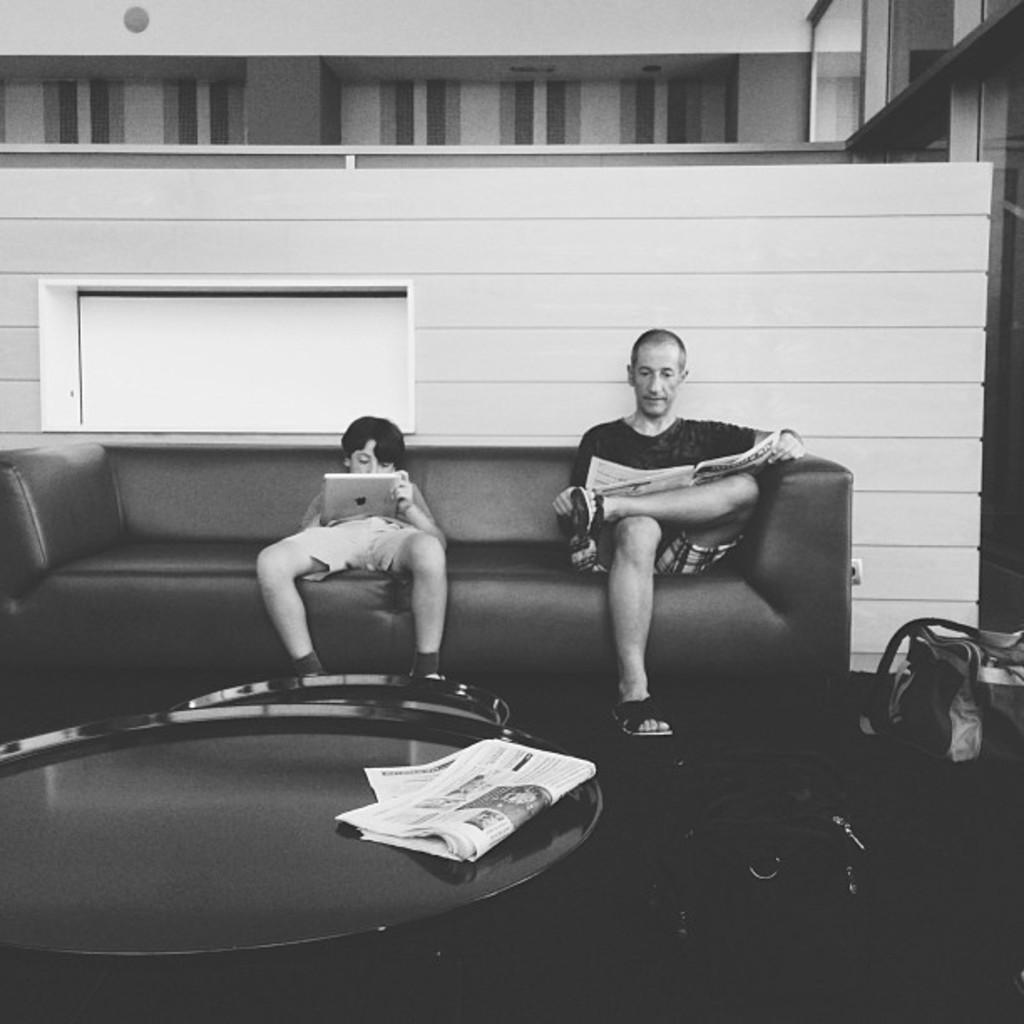How many people are sitting on the couch in the image? There are two people sitting on the couch in the image. What is located in front of the couch? There is a teapoy in front of the couch. What is on the teapoy? There is a paper on the teapoy. What is on the floor near the couch? There is a bag on the floor. What type of bun is being used as a backrest for the people sitting on the couch? There is no bun present in the image; it features two people sitting on a couch with a teapoy in front of it. 